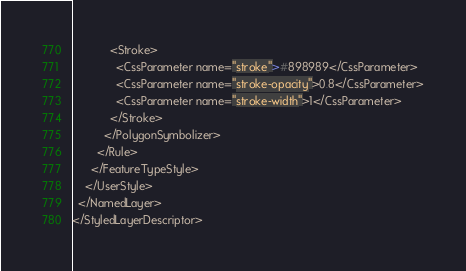<code> <loc_0><loc_0><loc_500><loc_500><_Scheme_>            <Stroke>
              <CssParameter name="stroke">#898989</CssParameter>
              <CssParameter name="stroke-opacity">0.8</CssParameter>
              <CssParameter name="stroke-width">1</CssParameter>
            </Stroke>
          </PolygonSymbolizer>
        </Rule>
      </FeatureTypeStyle>
    </UserStyle>
  </NamedLayer>
</StyledLayerDescriptor>
</code> 